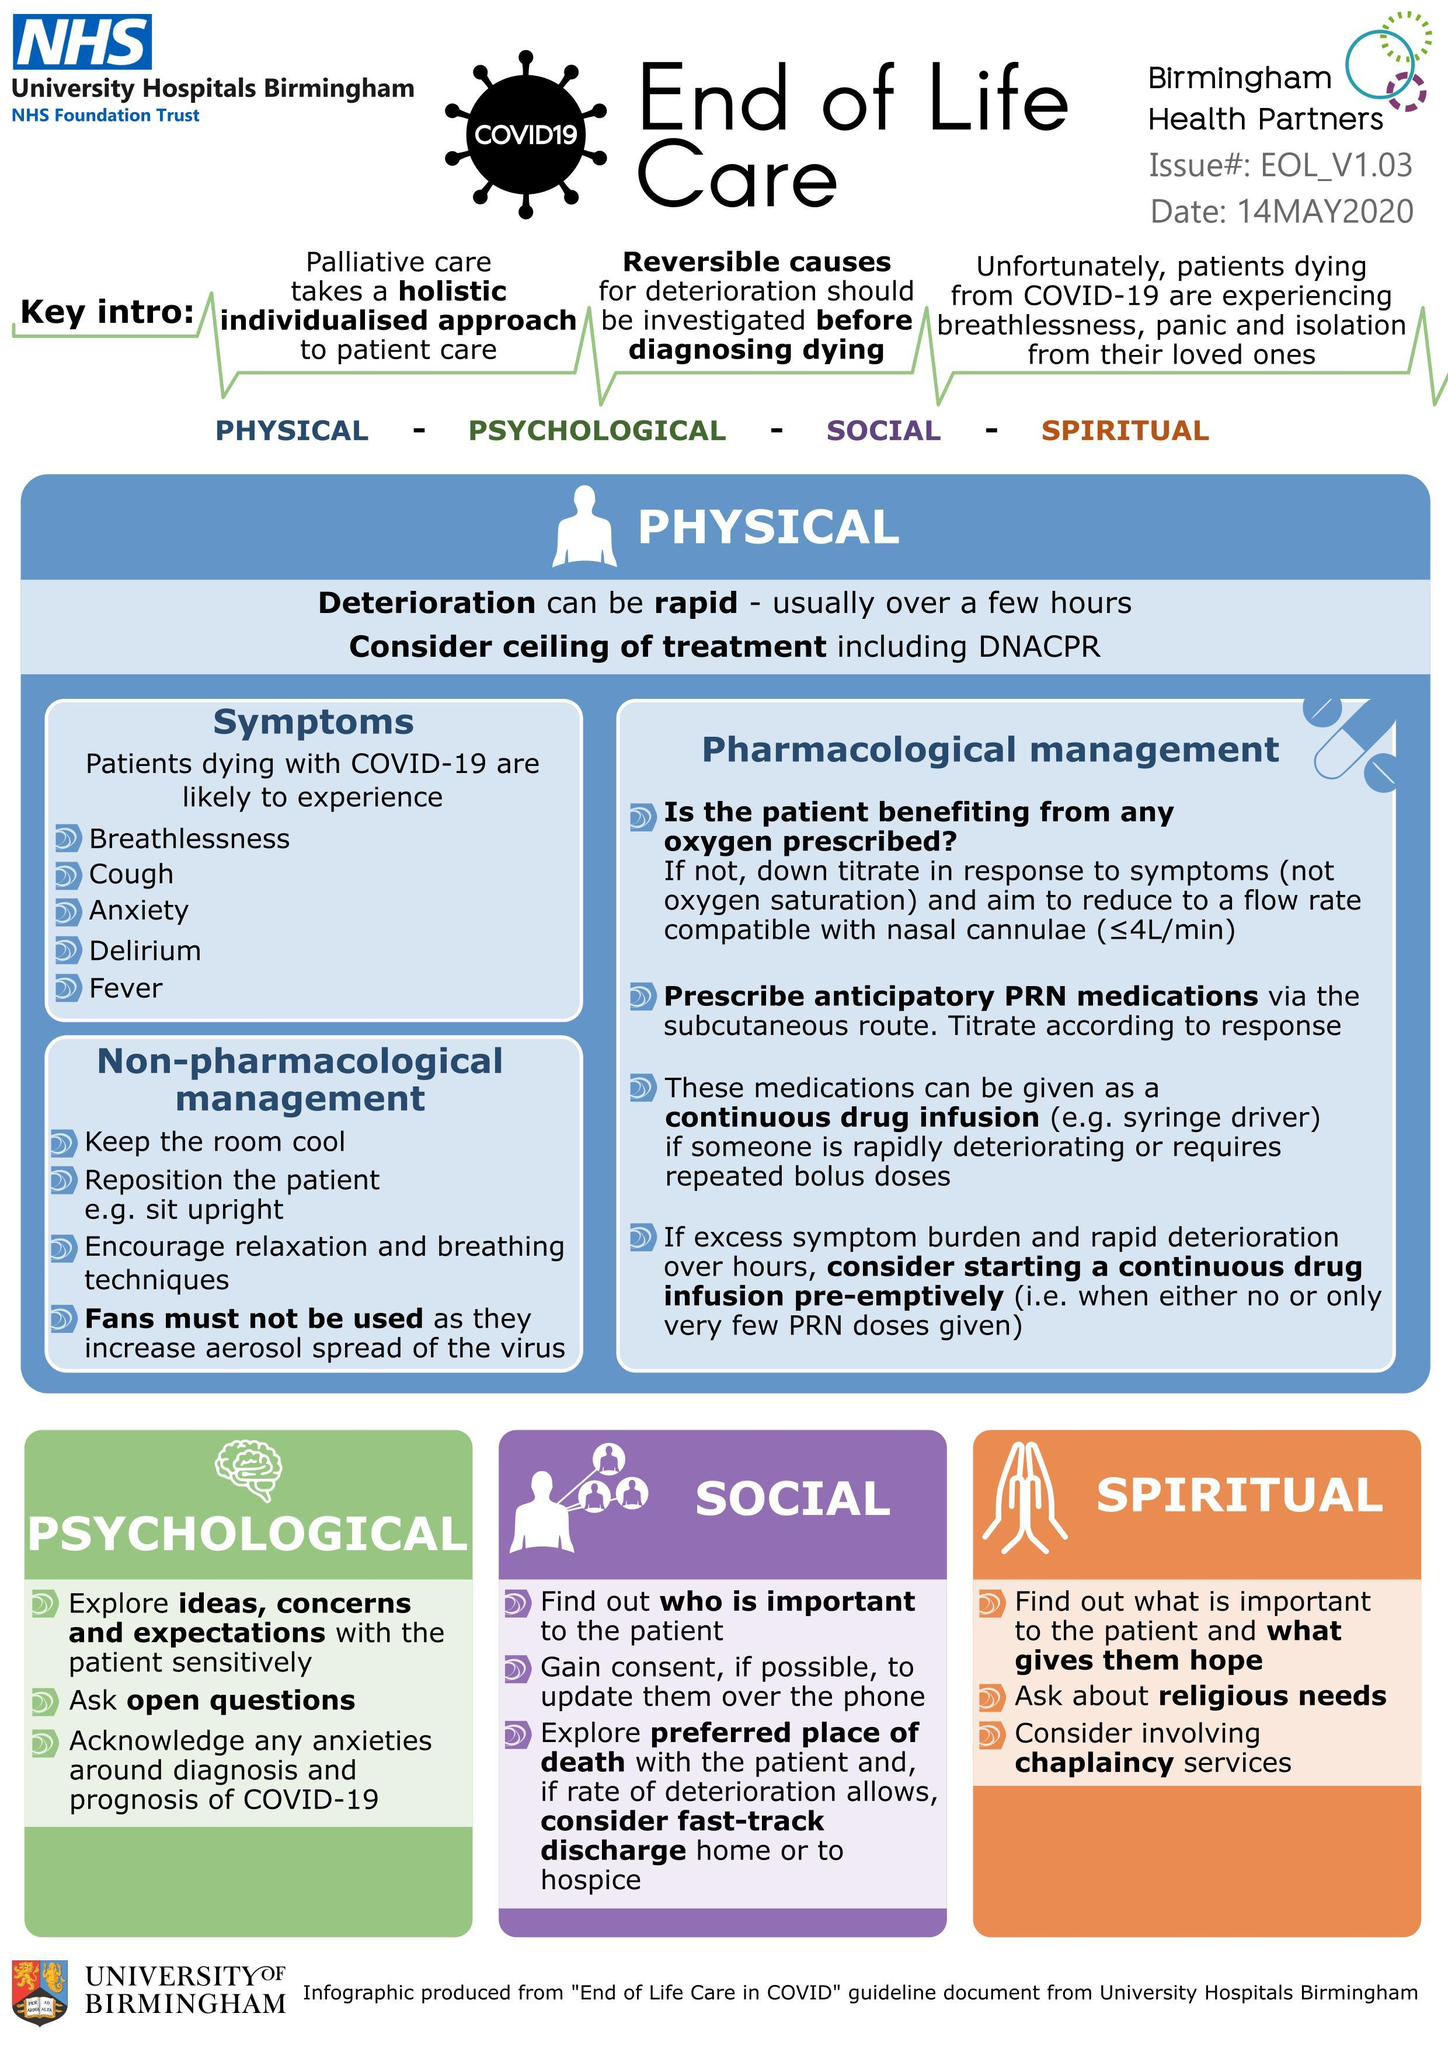what increase aerosol spread of the virus
Answer the question with a short phrase. fans what should be investigated before diagnosis dying reversible causes for deterioration keeping the room cool is which aspect of physical treatment non-pharmacological management how many treatments are being considered in end of life care 4 How many symptoms are dying patients likely to experience 5 In which treatment are open questions asked psychological in which part of treatment should the religious needs be enquired spiritual 